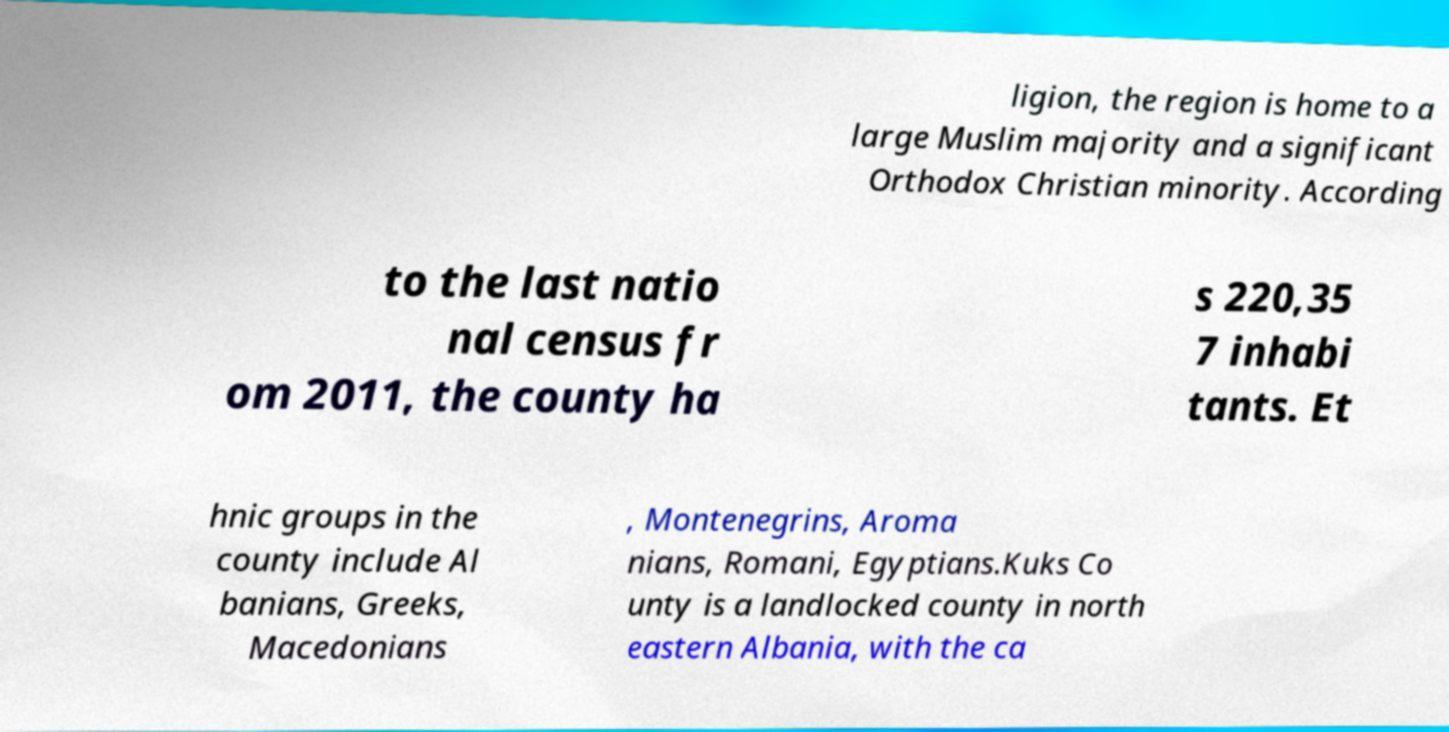Please read and relay the text visible in this image. What does it say? ligion, the region is home to a large Muslim majority and a significant Orthodox Christian minority. According to the last natio nal census fr om 2011, the county ha s 220,35 7 inhabi tants. Et hnic groups in the county include Al banians, Greeks, Macedonians , Montenegrins, Aroma nians, Romani, Egyptians.Kuks Co unty is a landlocked county in north eastern Albania, with the ca 